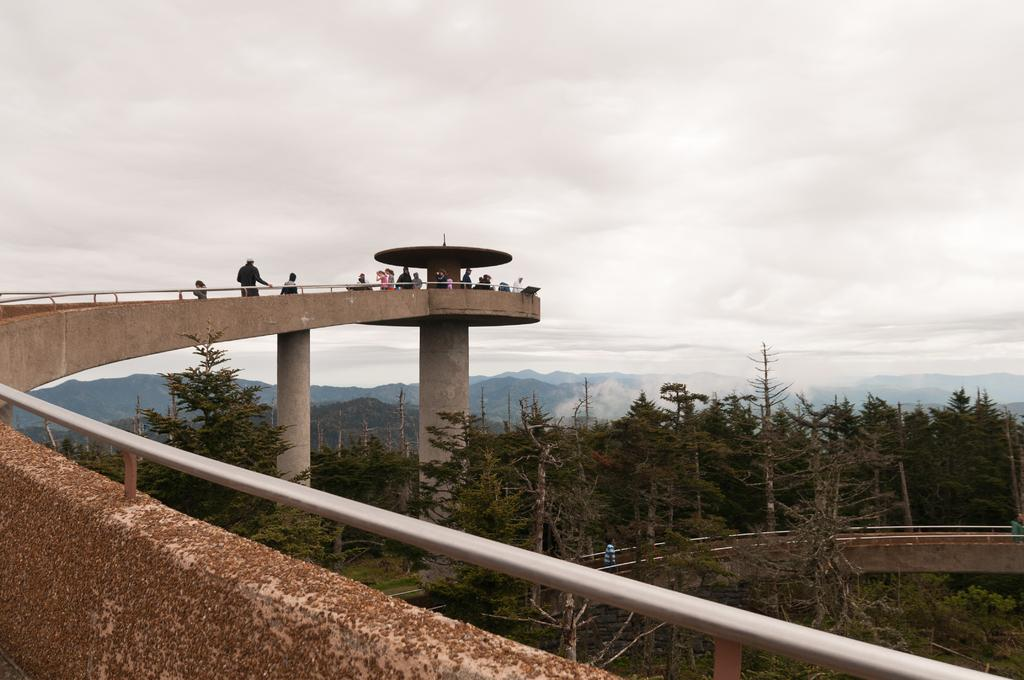What can be seen on the bridge in the image? There are people on the bridge in the image. What type of vegetation is present in the image? There are trees in the image. What natural features can be seen in the background? There are mountains in the image. What is visible in the sky? There are clouds in the sky. How does the belief system of the people on the bridge affect the river's flow? There is no river present in the image, and therefore its flow cannot be affected by any belief system. 